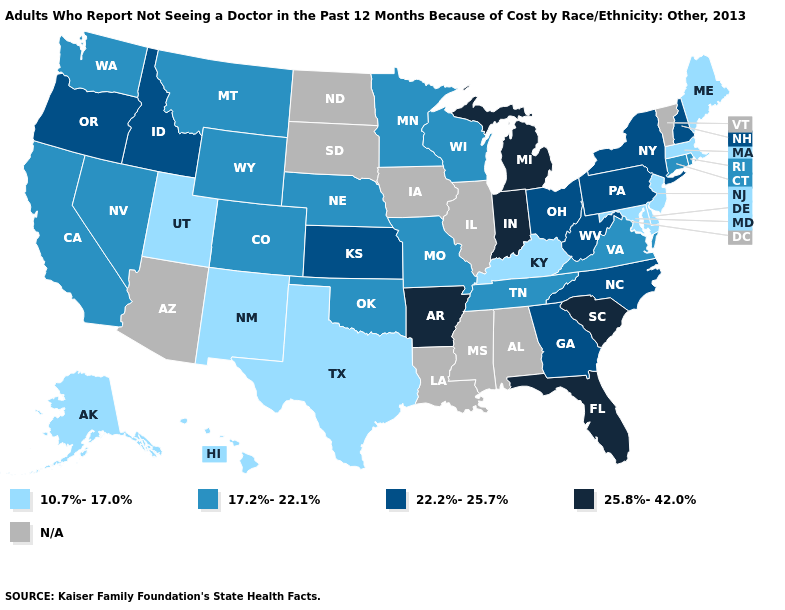What is the value of Rhode Island?
Keep it brief. 17.2%-22.1%. Name the states that have a value in the range 17.2%-22.1%?
Short answer required. California, Colorado, Connecticut, Minnesota, Missouri, Montana, Nebraska, Nevada, Oklahoma, Rhode Island, Tennessee, Virginia, Washington, Wisconsin, Wyoming. Name the states that have a value in the range 10.7%-17.0%?
Be succinct. Alaska, Delaware, Hawaii, Kentucky, Maine, Maryland, Massachusetts, New Jersey, New Mexico, Texas, Utah. Name the states that have a value in the range 22.2%-25.7%?
Short answer required. Georgia, Idaho, Kansas, New Hampshire, New York, North Carolina, Ohio, Oregon, Pennsylvania, West Virginia. Does Pennsylvania have the lowest value in the USA?
Answer briefly. No. Does West Virginia have the highest value in the South?
Keep it brief. No. Name the states that have a value in the range N/A?
Answer briefly. Alabama, Arizona, Illinois, Iowa, Louisiana, Mississippi, North Dakota, South Dakota, Vermont. Which states hav the highest value in the South?
Write a very short answer. Arkansas, Florida, South Carolina. Does the first symbol in the legend represent the smallest category?
Keep it brief. Yes. Among the states that border Virginia , which have the lowest value?
Concise answer only. Kentucky, Maryland. What is the value of Georgia?
Answer briefly. 22.2%-25.7%. What is the highest value in the USA?
Short answer required. 25.8%-42.0%. What is the highest value in states that border Minnesota?
Quick response, please. 17.2%-22.1%. Name the states that have a value in the range 25.8%-42.0%?
Concise answer only. Arkansas, Florida, Indiana, Michigan, South Carolina. What is the value of New Jersey?
Concise answer only. 10.7%-17.0%. 